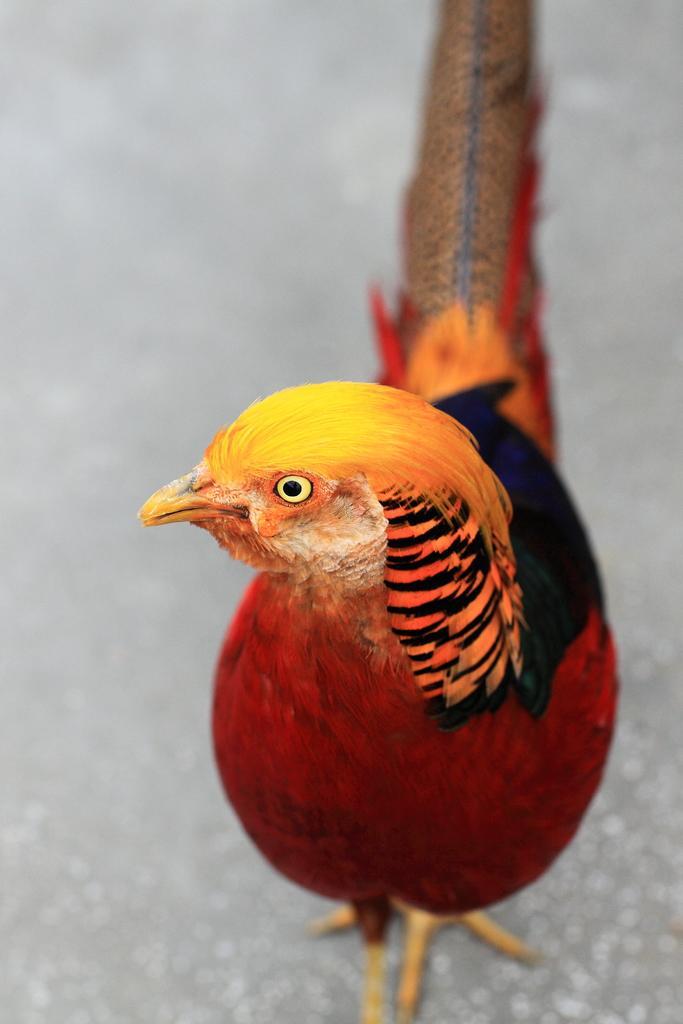In one or two sentences, can you explain what this image depicts? In this picture we can see a colorful hen. 